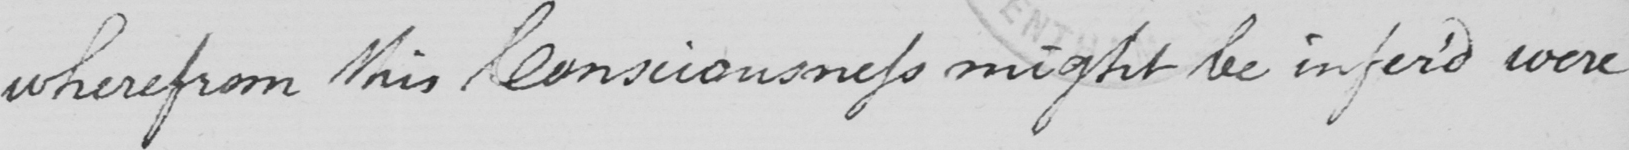What text is written in this handwritten line? wherefrom this Consciousness might be infer'd were 